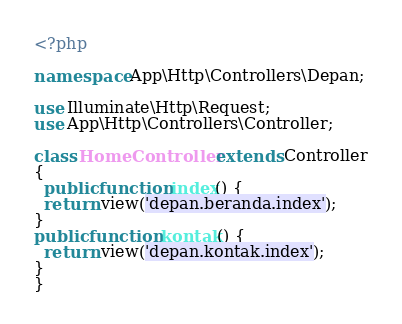Convert code to text. <code><loc_0><loc_0><loc_500><loc_500><_PHP_><?php

namespace App\Http\Controllers\Depan;

use Illuminate\Http\Request;
use App\Http\Controllers\Controller;

class HomeController extends Controller
{
  public function index() {
  return view('depan.beranda.index');
}
public function kontak() {
  return view('depan.kontak.index');
}
}
</code> 